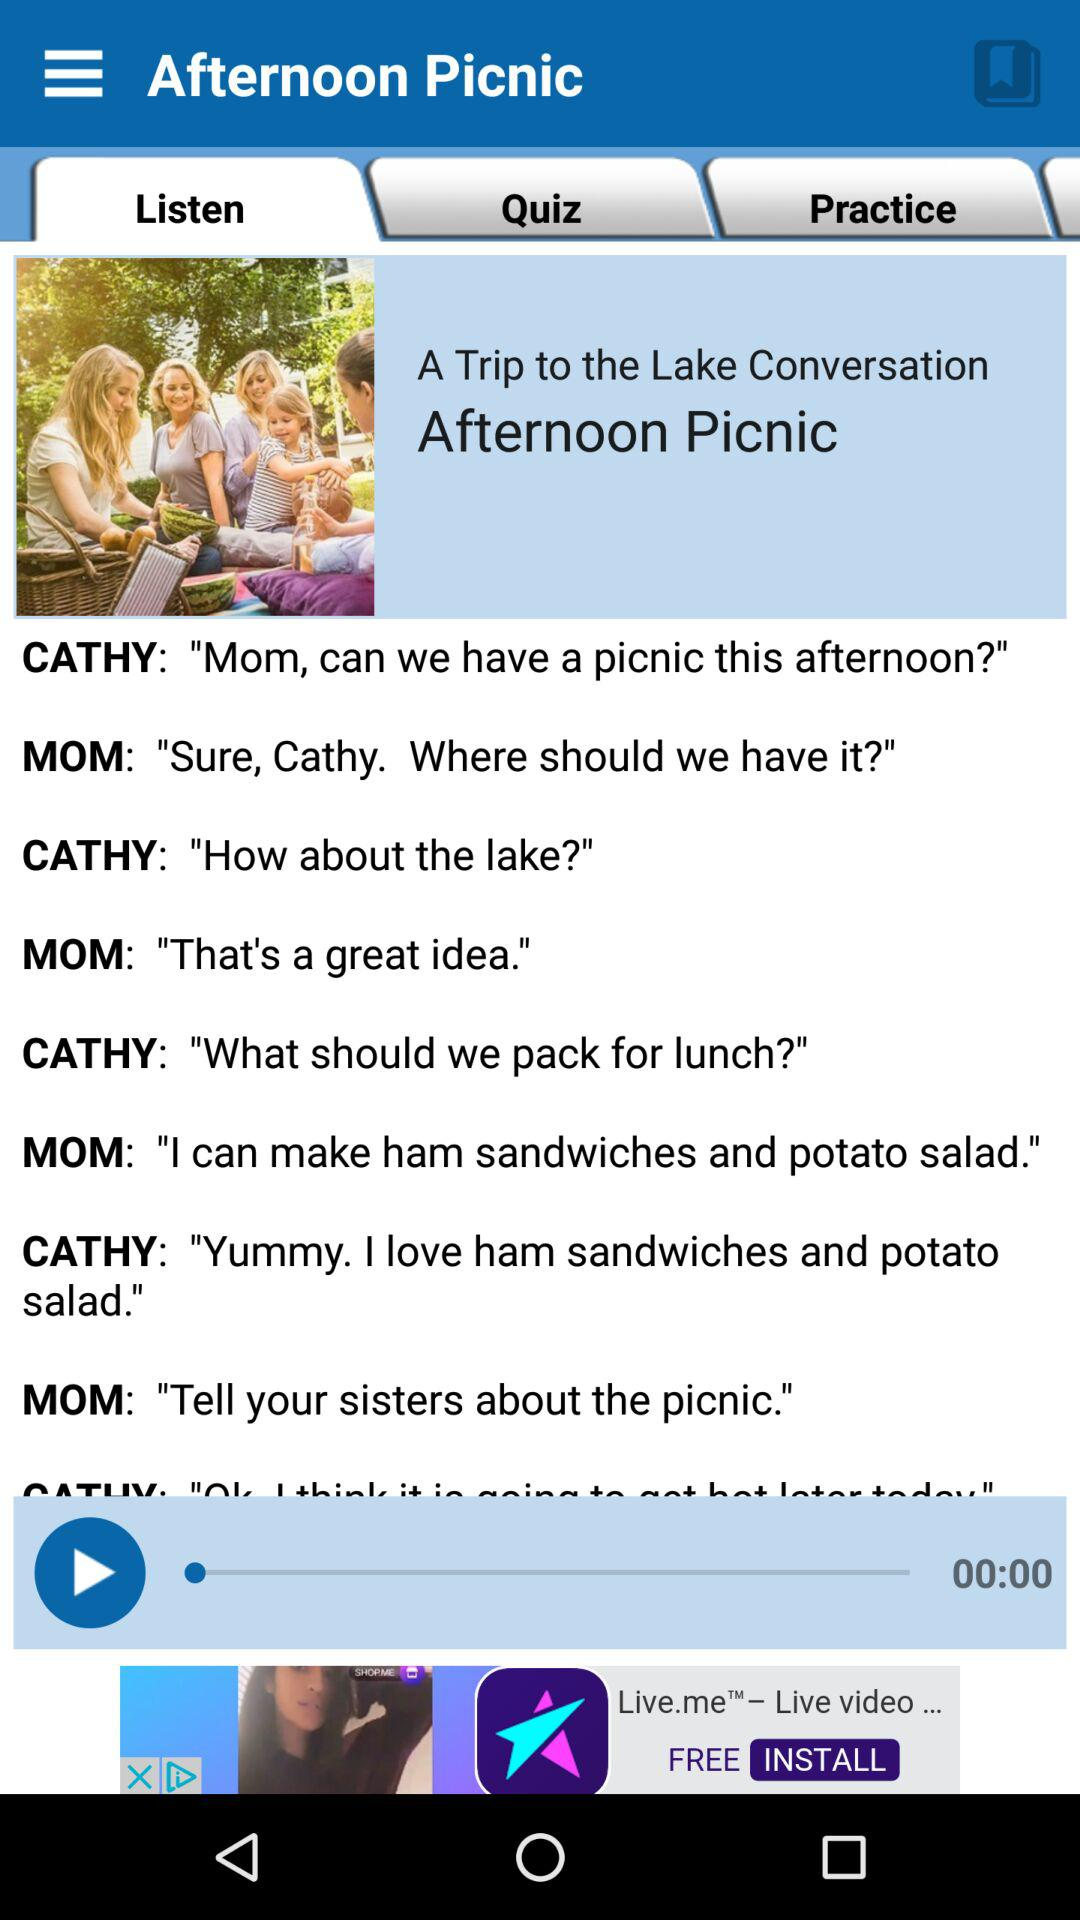What should they pack for lunch? For lunch, they should have packed ham sandwiches and potato salad. 